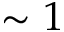Convert formula to latex. <formula><loc_0><loc_0><loc_500><loc_500>\sim 1</formula> 